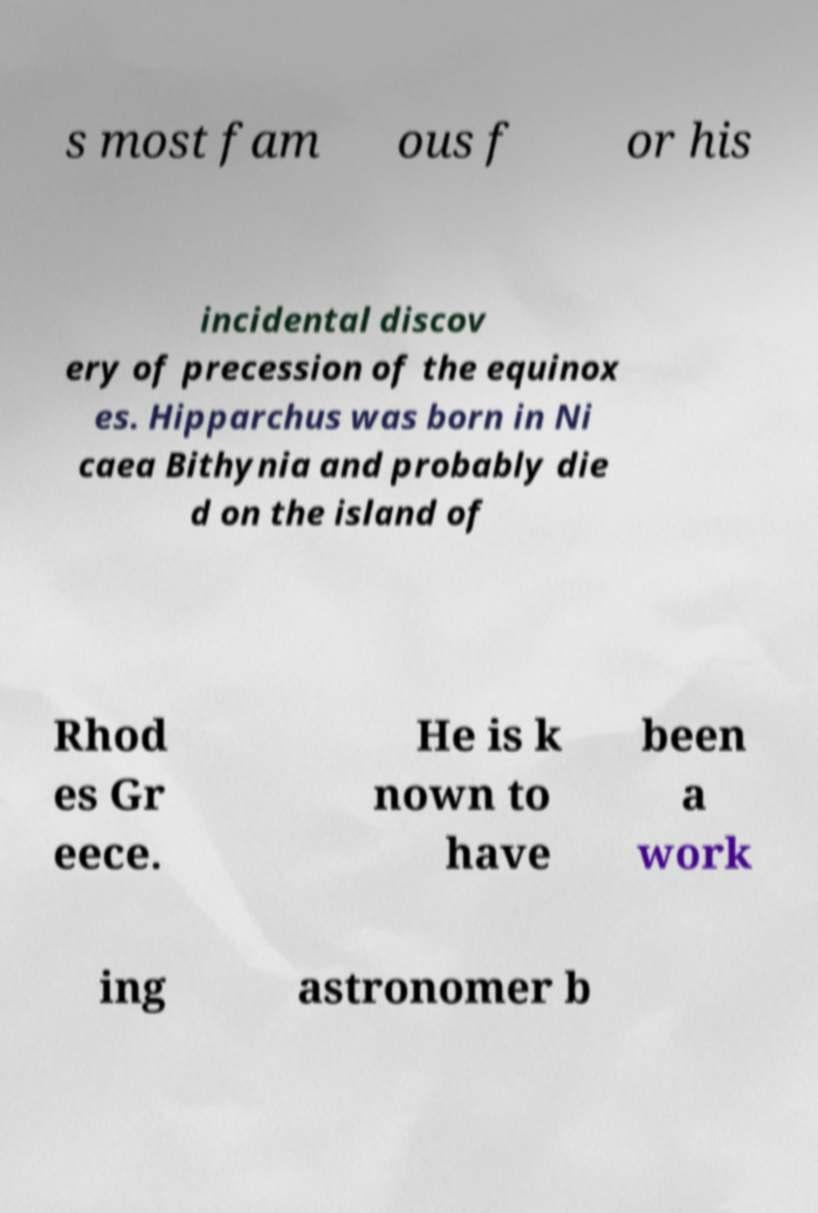Please read and relay the text visible in this image. What does it say? s most fam ous f or his incidental discov ery of precession of the equinox es. Hipparchus was born in Ni caea Bithynia and probably die d on the island of Rhod es Gr eece. He is k nown to have been a work ing astronomer b 